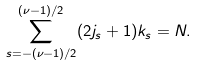<formula> <loc_0><loc_0><loc_500><loc_500>\sum _ { s = - ( \nu - 1 ) / 2 } ^ { ( \nu - 1 ) / 2 } ( 2 j _ { s } + 1 ) k _ { s } = N .</formula> 